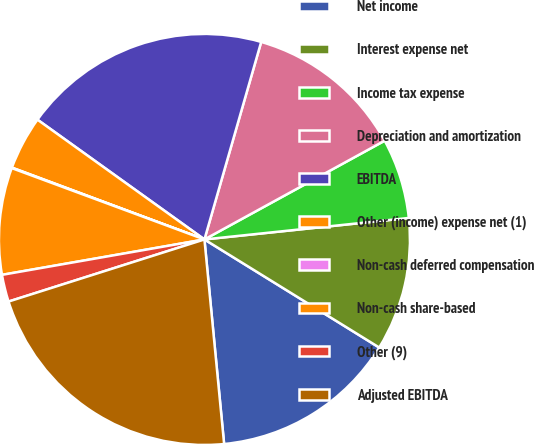Convert chart to OTSL. <chart><loc_0><loc_0><loc_500><loc_500><pie_chart><fcel>Net income<fcel>Interest expense net<fcel>Income tax expense<fcel>Depreciation and amortization<fcel>EBITDA<fcel>Other (income) expense net (1)<fcel>Non-cash deferred compensation<fcel>Non-cash share-based<fcel>Other (9)<fcel>Adjusted EBITDA<nl><fcel>14.66%<fcel>10.48%<fcel>6.31%<fcel>12.57%<fcel>19.55%<fcel>4.22%<fcel>0.04%<fcel>8.4%<fcel>2.13%<fcel>21.64%<nl></chart> 